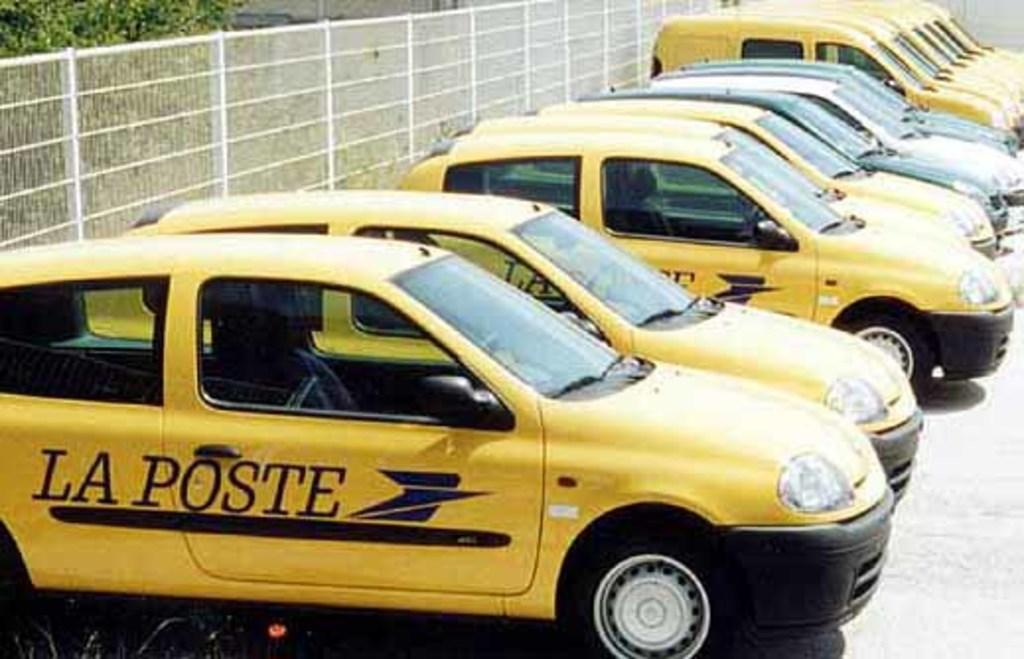<image>
Create a compact narrative representing the image presented. Here's a lineup of La Poste's mostly yellow fleet of vehicles in a parking area. 